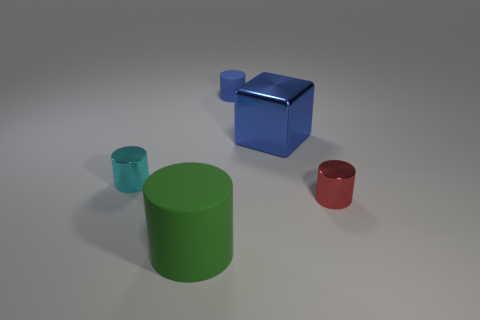There is a large object in front of the red object; does it have the same shape as the tiny shiny object that is left of the tiny red cylinder?
Your response must be concise. Yes. What material is the tiny thing that is in front of the tiny metal cylinder that is to the left of the tiny thing to the right of the shiny block made of?
Offer a very short reply. Metal. The rubber thing that is the same size as the blue metallic thing is what shape?
Your answer should be very brief. Cylinder. Are there any rubber objects of the same color as the large metal thing?
Offer a terse response. Yes. How big is the cyan cylinder?
Give a very brief answer. Small. Do the large blue cube and the cyan cylinder have the same material?
Provide a short and direct response. Yes. There is a small thing behind the tiny metallic thing that is left of the big cylinder; how many red shiny things are in front of it?
Ensure brevity in your answer.  1. What is the shape of the big thing in front of the cyan shiny cylinder?
Offer a very short reply. Cylinder. How many other things are made of the same material as the blue cube?
Keep it short and to the point. 2. Is the color of the big metal thing the same as the big cylinder?
Provide a short and direct response. No. 